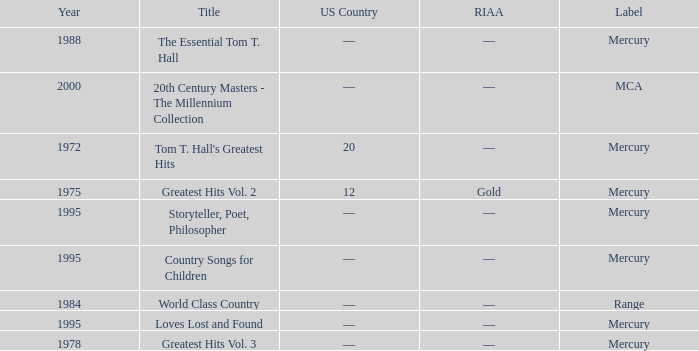What label had the album after 1978? Range, Mercury, Mercury, Mercury, Mercury, MCA. 